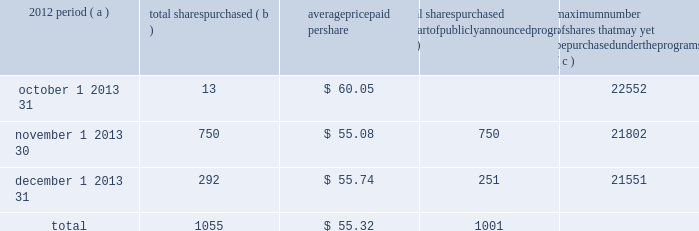Part ii item 5 2013 market for registrant 2019s common equity , related stockholder matters and issuer purchases of equity securities ( a ) ( 1 ) our common stock is listed on the new york stock exchange and is traded under the symbol 201cpnc . 201d at the close of business on february 15 , 2013 , there were 75100 common shareholders of record .
Holders of pnc common stock are entitled to receive dividends when declared by the board of directors out of funds legally available for this purpose .
Our board of directors may not pay or set apart dividends on the common stock until dividends for all past dividend periods on any series of outstanding preferred stock have been paid or declared and set apart for payment .
The board presently intends to continue the policy of paying quarterly cash dividends .
The amount of any future dividends will depend on economic and market conditions , our financial condition and operating results , and other factors , including contractual restrictions and applicable government regulations and policies ( such as those relating to the ability of bank and non- bank subsidiaries to pay dividends to the parent company and regulatory capital limitations ) .
The amount of our dividend is also currently subject to the results of the federal reserve 2019s 2013 comprehensive capital analysis and review ( ccar ) as part of its supervisory assessment of capital adequacy described under 201csupervision and regulation 201d in item 1 of this report .
The federal reserve has the power to prohibit us from paying dividends without its approval .
For further information concerning dividend restrictions and restrictions on loans , dividends or advances from bank subsidiaries to the parent company , see 201csupervision and regulation 201d in item 1 of this report , 201cfunding and capital sources 201d in the consolidated balance sheet review section , 201cliquidity risk management 201d in the risk management section , and 201ctrust preferred securities 201d in the off-balance sheet arrangements and variable interest entities section of item 7 of this report , and note 14 capital securities of subsidiary trusts and perpetual trust securities and note 22 regulatory matters in the notes to consolidated financial statements in item 8 of this report , which we include here by reference .
We include here by reference additional information relating to pnc common stock under the caption 201ccommon stock prices/dividends declared 201d in the statistical information ( unaudited ) section of item 8 of this report .
We include here by reference the information regarding our compensation plans under which pnc equity securities are authorized for issuance as of december 31 , 2012 in the table ( with introductory paragraph and notes ) that appears in item 12 of this report .
Our registrar , stock transfer agent , and dividend disbursing agent is : computershare trust company , n.a .
250 royall street canton , ma 02021 800-982-7652 we include here by reference the information that appears under the caption 201ccommon stock performance graph 201d at the end of this item 5 .
( a ) ( 2 ) none .
( b ) not applicable .
( c ) details of our repurchases of pnc common stock during the fourth quarter of 2012 are included in the table : in thousands , except per share data 2012 period ( a ) total shares purchased ( b ) average paid per total shares purchased as part of publicly announced programs ( c ) maximum number of shares that may yet be purchased under the programs ( c ) .
( a ) in addition to the repurchases of pnc common stock during the fourth quarter of 2012 included in the table above , pnc redeemed all 5001 shares of its series m preferred stock on december 10 , 2012 as further described below .
As part of the national city transaction , we established the pnc non-cumulative perpetual preferred stock , series m ( the 201cseries m preferred stock 201d ) , which mirrored in all material respects the former national city non-cumulative perpetual preferred stock , series e .
On december 10 , 2012 , pnc issued $ 500.1 million aggregate liquidation amount ( 5001 shares ) of the series m preferred stock to the national city preferred capital trust i ( the 201ctrust 201d ) as required pursuant to the settlement of a stock purchase contract agreement between the trust and pnc dated as of january 30 , 2008 .
Immediately upon such issuance , pnc redeemed all 5001 shares of the series m preferred stock from the trust on december 10 , 2012 at a redemption price equal to $ 100000 per share .
( b ) includes pnc common stock purchased under the program referred to in note ( c ) to this table and pnc common stock purchased in connection with our various employee benefit plans .
Note 15 employee benefit plans and note 16 stock based compensation plans in the notes to consolidated financial statements in item 8 of this report include additional information regarding our employee benefit plans that use pnc common stock .
( c ) our current stock repurchase program allows us to purchase up to 25 million shares on the open market or in privately negotiated transactions .
This program was authorized on october 4 , 2007 and will remain in effect until fully utilized or until modified , superseded or terminated .
The extent and timing of share repurchases under this program will depend on a number of factors including , among others , market and general economic conditions , economic capital and regulatory capital considerations , alternative uses of capital , the potential impact on our credit ratings , and contractual and regulatory limitations , including the impact of the federal reserve 2019s supervisory assessment of capital adequacy program .
The pnc financial services group , inc .
2013 form 10-k 27 .
What is the mathematical range for the stock prices in oct , nov and dec? 
Computations: (60.05 - 55.08)
Answer: 4.97. 